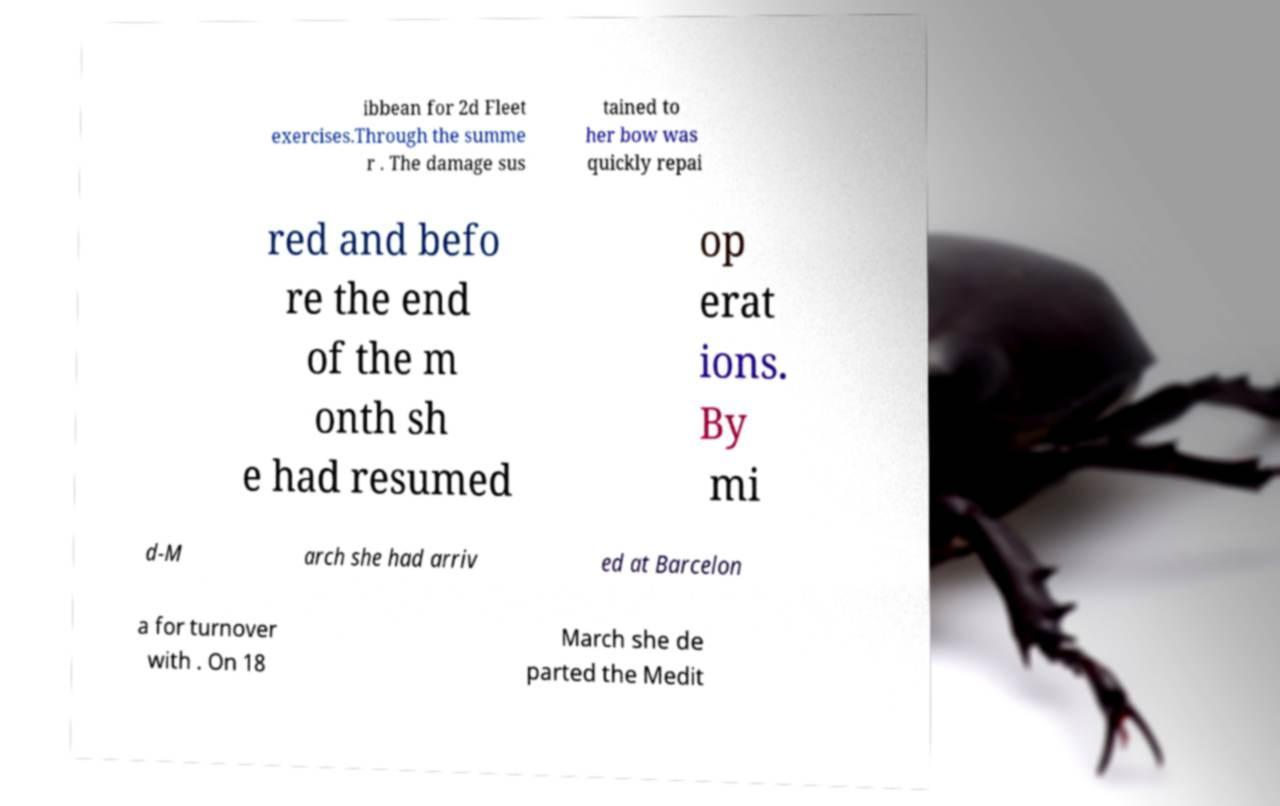Please identify and transcribe the text found in this image. ibbean for 2d Fleet exercises.Through the summe r . The damage sus tained to her bow was quickly repai red and befo re the end of the m onth sh e had resumed op erat ions. By mi d-M arch she had arriv ed at Barcelon a for turnover with . On 18 March she de parted the Medit 